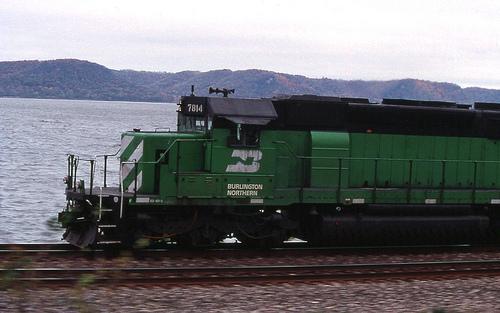How many trains are in the photo?
Give a very brief answer. 1. 